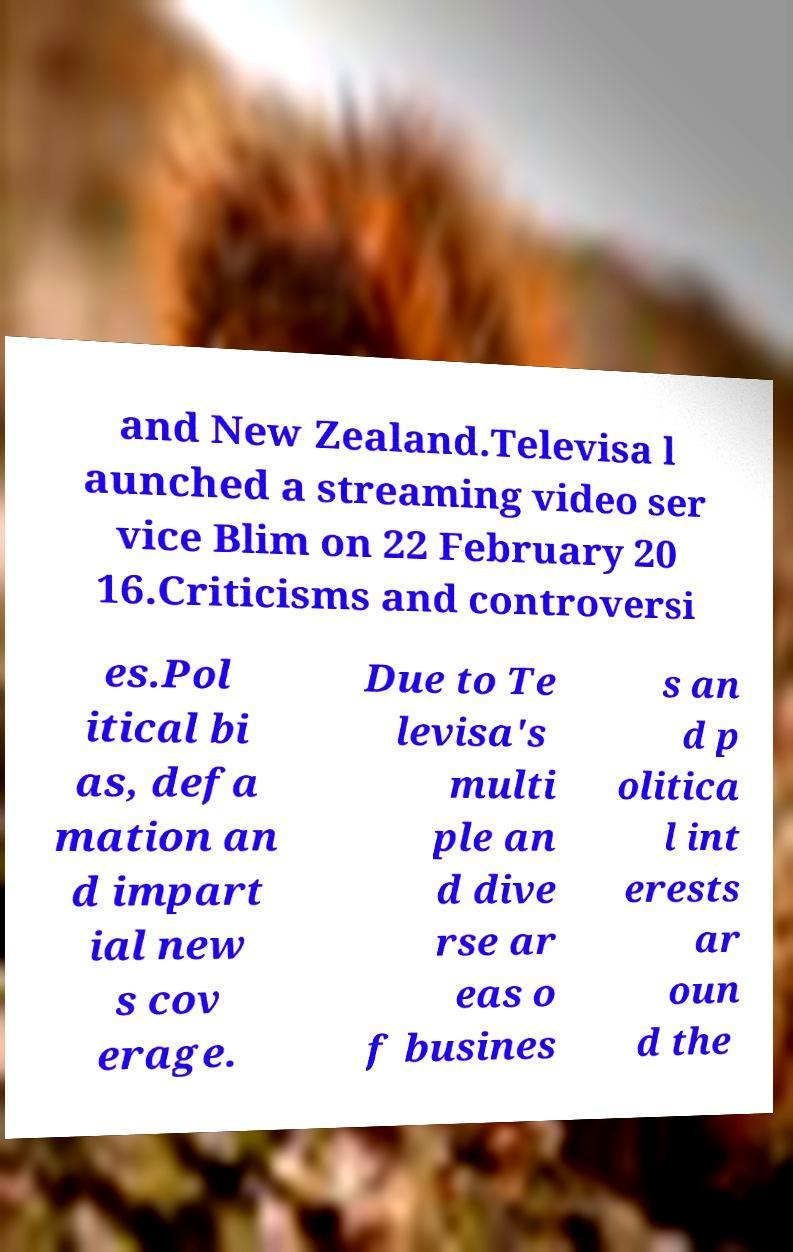There's text embedded in this image that I need extracted. Can you transcribe it verbatim? and New Zealand.Televisa l aunched a streaming video ser vice Blim on 22 February 20 16.Criticisms and controversi es.Pol itical bi as, defa mation an d impart ial new s cov erage. Due to Te levisa's multi ple an d dive rse ar eas o f busines s an d p olitica l int erests ar oun d the 